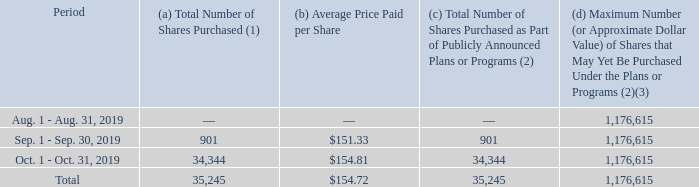Item 5. Market for the Registrant’s Common Equity, Related Stockholder Matters and Issuer Purchases of Equity Securities.
The Company’s common stock is traded on the NASDAQ Stock Market LLC under the symbol SAFM.
The number of stockholders of record as of December 12, 2019, was 2,742. The number of beneficial owners of our stock is greater than the number of holders of record, and the exact number is unknown.
The amount of future common stock dividends will depend on our earnings, financial condition, capital requirements, the effect a dividend would have on the Company's compliance with financial covenants and other factors, which will be considered by the Board of Directors on a quarterly basis.
During its fourth fiscal quarter, the Company repurchased shares of its common stock as follows:
1  All purchases were made pursuant to the Company's Stock Incentive Plan, as amended and restated on February 11, 2016, under which shares were withheld to satisfy tax withholding obligations.
2  On May 31, 2018, the Company’s Board of Directors expanded and extended the share repurchase program originally approved on October 22, 2009, under which the Company was originally authorized to purchase up to one million shares of its common stock and is now authorized to purchase up to two million shares of its common stock in open market transactions or negotiated purchases, subject to market conditions, share price and other considerations. The authorization will expire on May 31, 2021. During the fourth quarter of fiscal 2018, the Company purchased 823,385 shares in open market transactions under this program. The Company’s repurchases of vested restricted stock to satisfy tax withholding obligations of its Stock Incentive Plan participants are not made under the 2018 general repurchase plan.
3  Does not include vested restricted shares that may yet be repurchased under the Stock Incentive Plan as described in Note 1.
Which market is the company's common stock traded on? Nasdaq stock market llc. What is the symbol of the company's common stock in the market? Safm. What is the total number of shares purchased in the fourth fiscal quarter? 35,245. What is the percentage constitution of the number of shares purchased in September 2019 among the total number of shares purchased in the fourth fiscal quarter?
Answer scale should be: percent. 901/35,245
Answer: 2.56. What is the difference in the total number of shares purchased between September 2019 and October 2019? 34,344-901
Answer: 33443. What is the change in the average price paid per share between September 2019 and October 2019? 154.81-151.33
Answer: 3.48. 